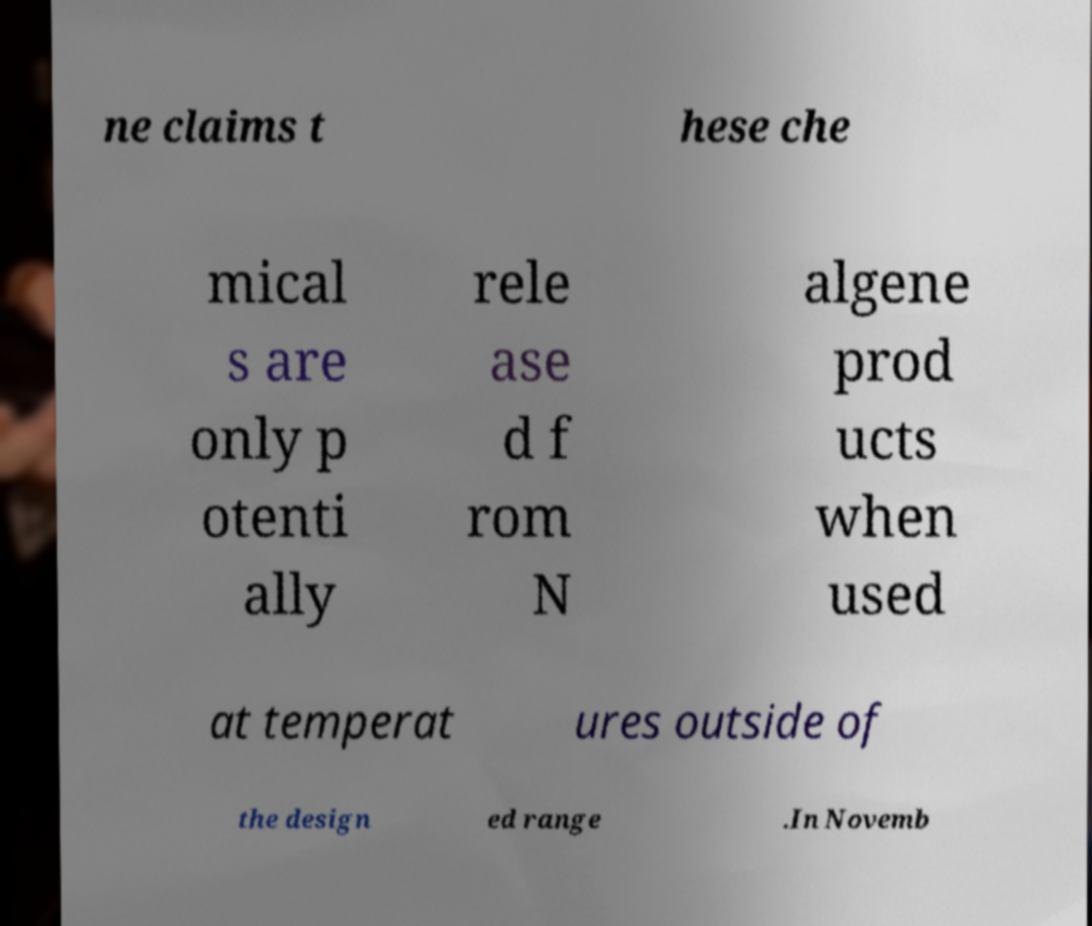Please read and relay the text visible in this image. What does it say? ne claims t hese che mical s are only p otenti ally rele ase d f rom N algene prod ucts when used at temperat ures outside of the design ed range .In Novemb 